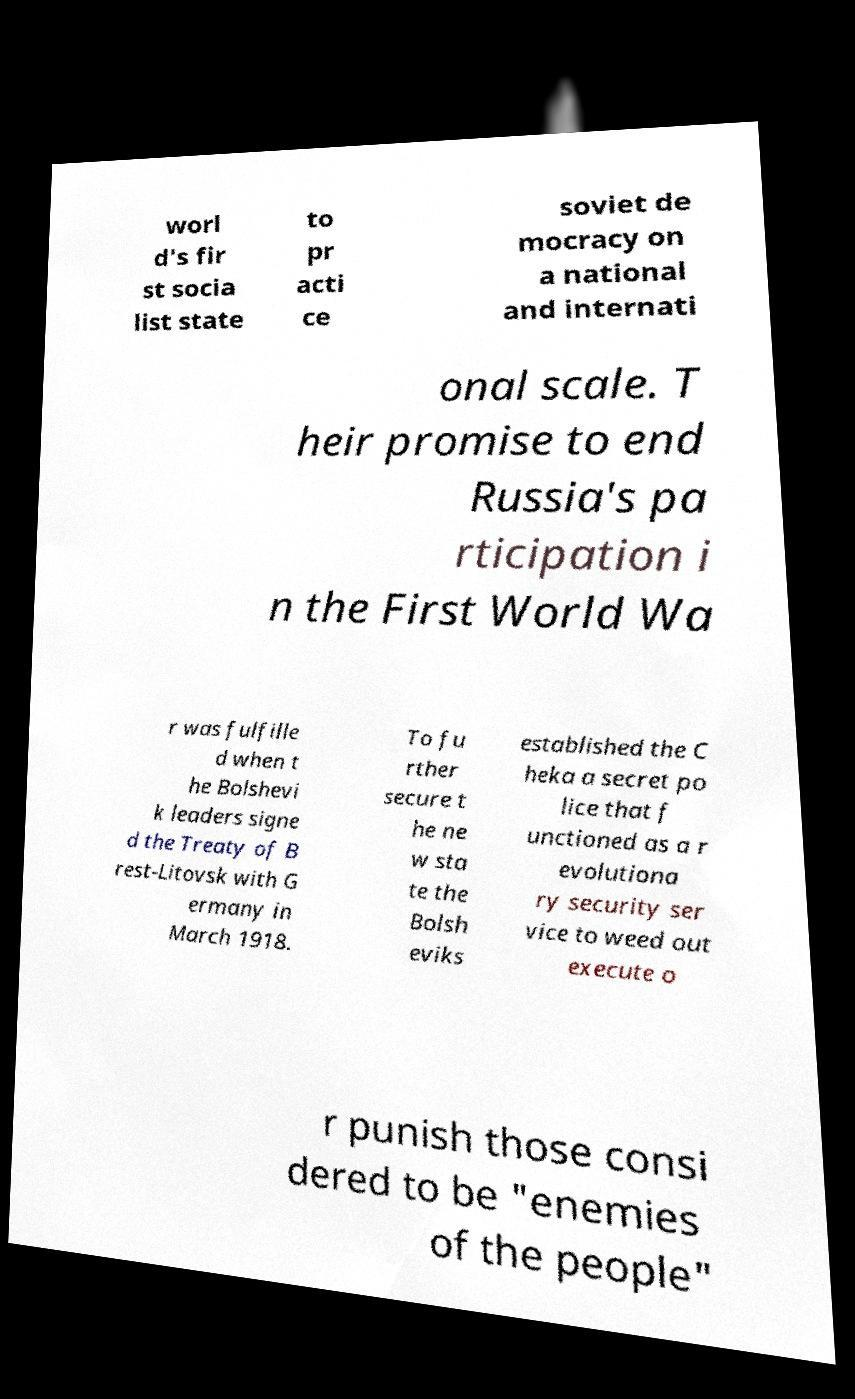For documentation purposes, I need the text within this image transcribed. Could you provide that? worl d's fir st socia list state to pr acti ce soviet de mocracy on a national and internati onal scale. T heir promise to end Russia's pa rticipation i n the First World Wa r was fulfille d when t he Bolshevi k leaders signe d the Treaty of B rest-Litovsk with G ermany in March 1918. To fu rther secure t he ne w sta te the Bolsh eviks established the C heka a secret po lice that f unctioned as a r evolutiona ry security ser vice to weed out execute o r punish those consi dered to be "enemies of the people" 